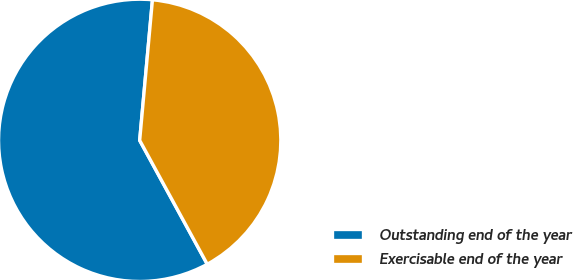Convert chart to OTSL. <chart><loc_0><loc_0><loc_500><loc_500><pie_chart><fcel>Outstanding end of the year<fcel>Exercisable end of the year<nl><fcel>59.39%<fcel>40.61%<nl></chart> 